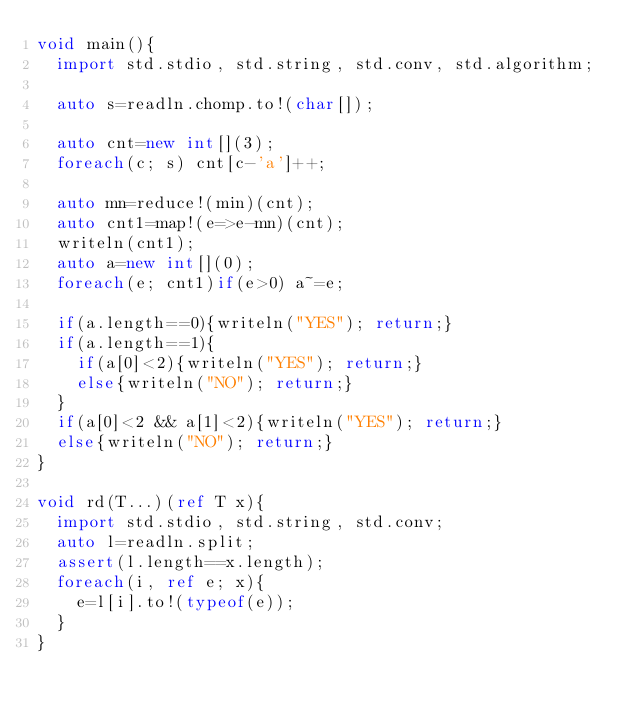Convert code to text. <code><loc_0><loc_0><loc_500><loc_500><_D_>void main(){
  import std.stdio, std.string, std.conv, std.algorithm;

  auto s=readln.chomp.to!(char[]);

  auto cnt=new int[](3);
  foreach(c; s) cnt[c-'a']++;

  auto mn=reduce!(min)(cnt);
  auto cnt1=map!(e=>e-mn)(cnt);
  writeln(cnt1);
  auto a=new int[](0);
  foreach(e; cnt1)if(e>0) a~=e;

  if(a.length==0){writeln("YES"); return;}
  if(a.length==1){
    if(a[0]<2){writeln("YES"); return;}
    else{writeln("NO"); return;}
  }
  if(a[0]<2 && a[1]<2){writeln("YES"); return;}
  else{writeln("NO"); return;}
}

void rd(T...)(ref T x){
  import std.stdio, std.string, std.conv;
  auto l=readln.split;
  assert(l.length==x.length);
  foreach(i, ref e; x){
    e=l[i].to!(typeof(e));
  }
}</code> 